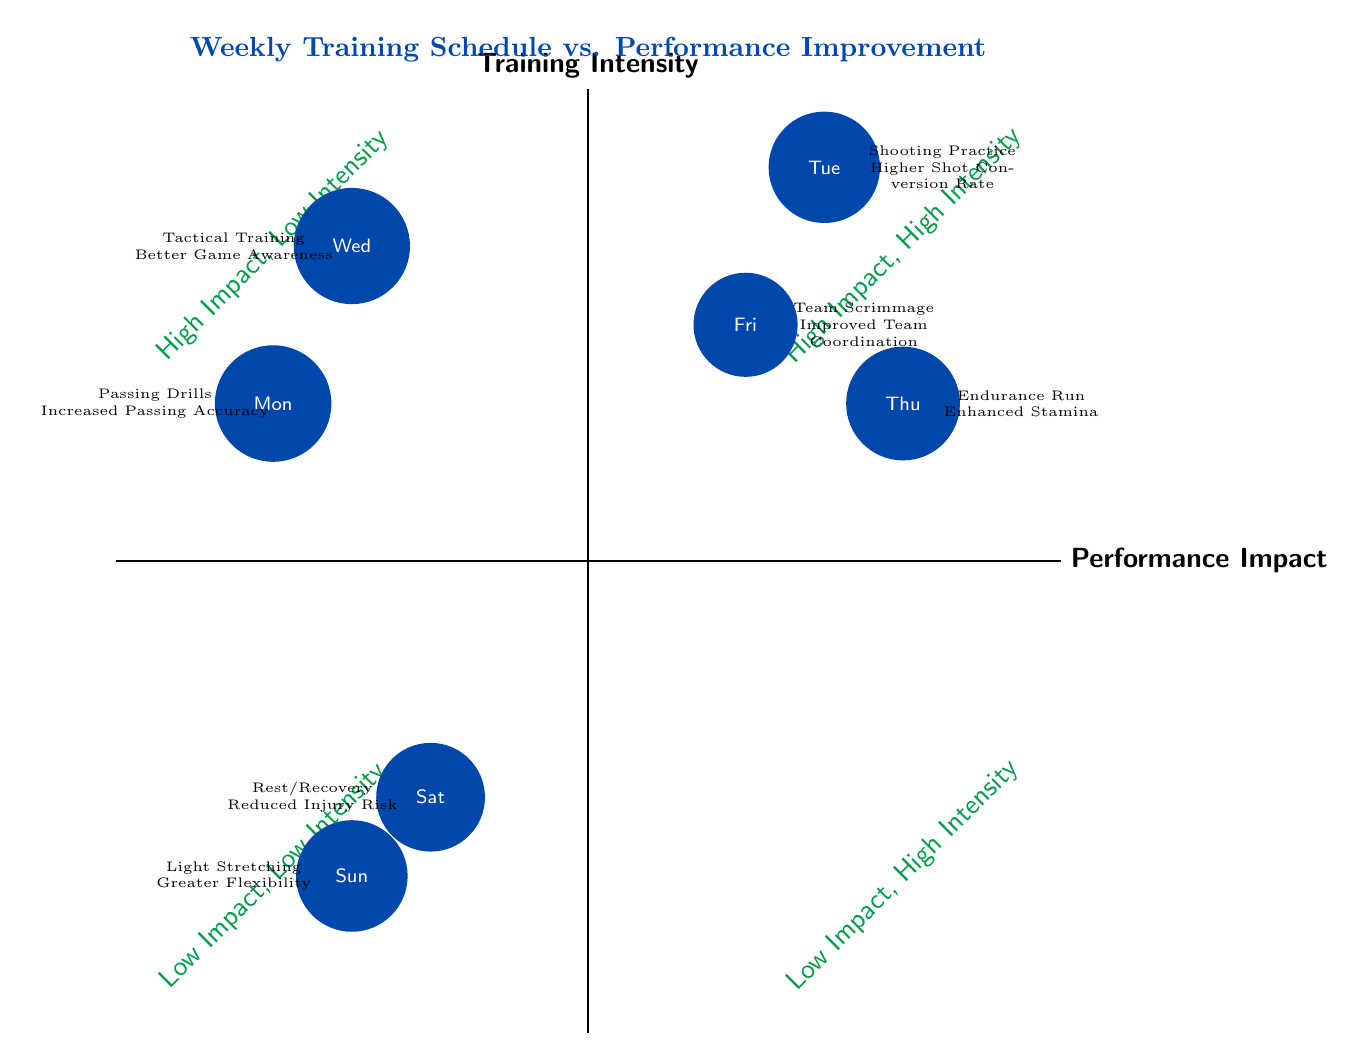What is the training activity on Tuesday? The diagram indicates that the activity for Tuesday is represented by the node located at that point on the chart. Referring to the information provided, it states "Shooting Practice."
Answer: Shooting Practice Which day has the performance improvement of "Reduced Injury Risk"? By examining the nodes within the lower quadrant of the chart, we can identify that "Rest/Recovery," which is linked to the performance improvement of "Reduced Injury Risk," corresponds to Saturday.
Answer: Saturday What performance improvement is associated with the Thursday training? The Thursday training is indicated on the chart and points to the performance improvement noted as “Enhanced Stamina.” This can be derived directly from the label near the Thursday node.
Answer: Enhanced Stamina How many training activities are in the "High Impact, Low Intensity" quadrant? Analyzing the nodes located in the "High Impact, Low Intensity" area of the chart, we find that there are two specific training activities, which are "Tactical Training" and "Passing Drills."
Answer: 2 Which performance improvement relates to "Team Scrimmage"? The Node for "Team Scrimmage" connects to the performance improvement of "Improved Team Coordination." This relationship is indicated clearly next to the relevant training node on the diagram.
Answer: Improved Team Coordination What is the relationship between "Light Stretching" and flexibility according to the diagram? The diagram shows that the node for "Light Stretching," which is on Sunday, is explicitly linked to the performance improvement of "Greater Flexibility." This highlights that the practice contributes directly to that specific improvement.
Answer: Greater Flexibility Where would you place the "Endurance Run" on the chart? The “Endurance Run” is located in the upper right quadrant, which corresponds to the area labeled “High Impact, High Intensity.” This placement can be confirmed by looking at its position and the overall layout of the chart.
Answer: High Impact, High Intensity Which day has a training activity with "Increased Passing Accuracy"? The node labeled for "Passing Drills," which corresponds to Monday, includes the performance improvement of “Increased Passing Accuracy.” This is found directly adjacent to the label for that day.
Answer: Monday 